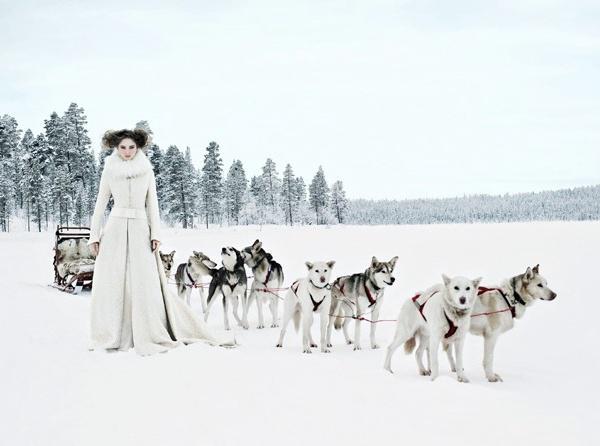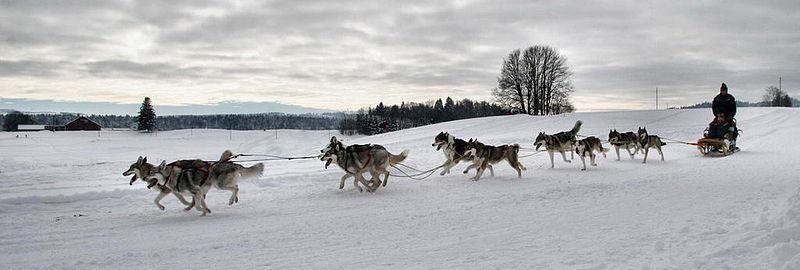The first image is the image on the left, the second image is the image on the right. Assess this claim about the two images: "The sled in the image on the left is unoccupied.". Correct or not? Answer yes or no. Yes. The first image is the image on the left, the second image is the image on the right. Given the left and right images, does the statement "In at least one image there is a single female with her hair showing and there are eight dogs attached to a sled." hold true? Answer yes or no. Yes. 